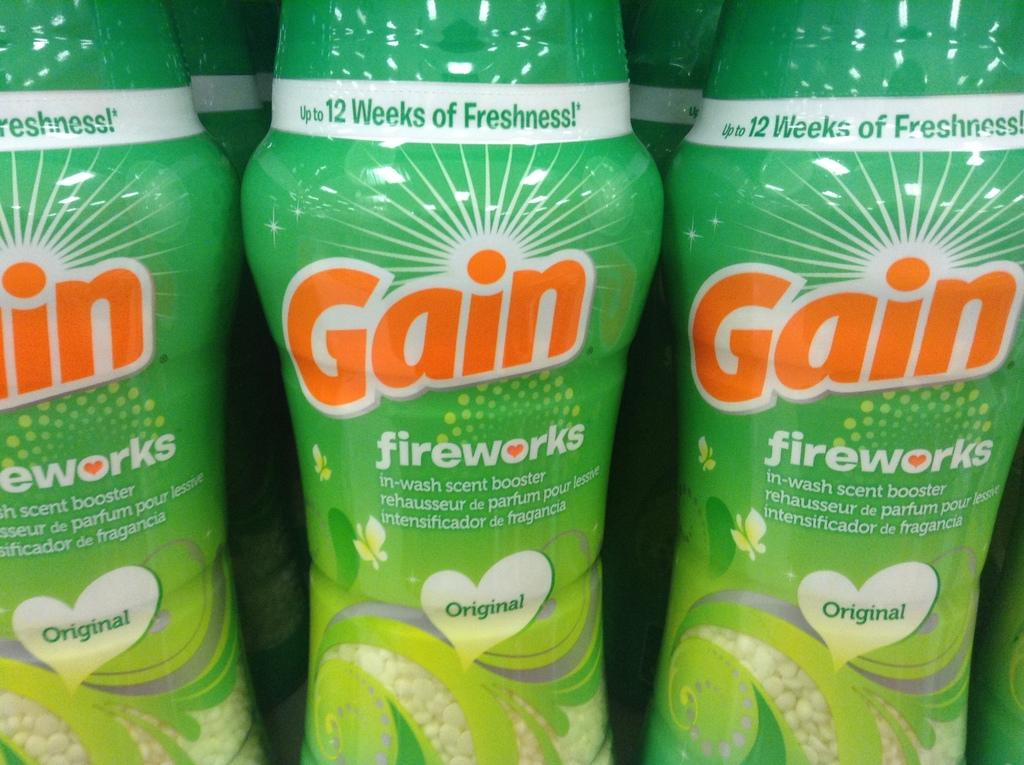What type of product is featured in the image? The image features perfume bottles. What is unique about each perfume bottle? Each perfume bottle has a sticker. What information is provided on the sticker? The sticker on each bottle mentions "Gain fireworks scent booster." What type of zipper can be seen on the perfume bottles in the image? There are no zippers present on the perfume bottles in the image. 